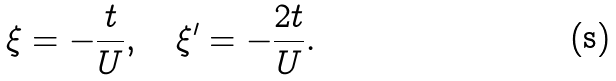<formula> <loc_0><loc_0><loc_500><loc_500>\xi = - \frac { t } { U } , \quad \xi ^ { \prime } = - \frac { 2 t } { U } .</formula> 